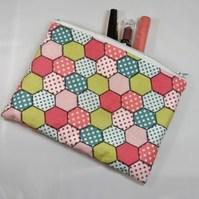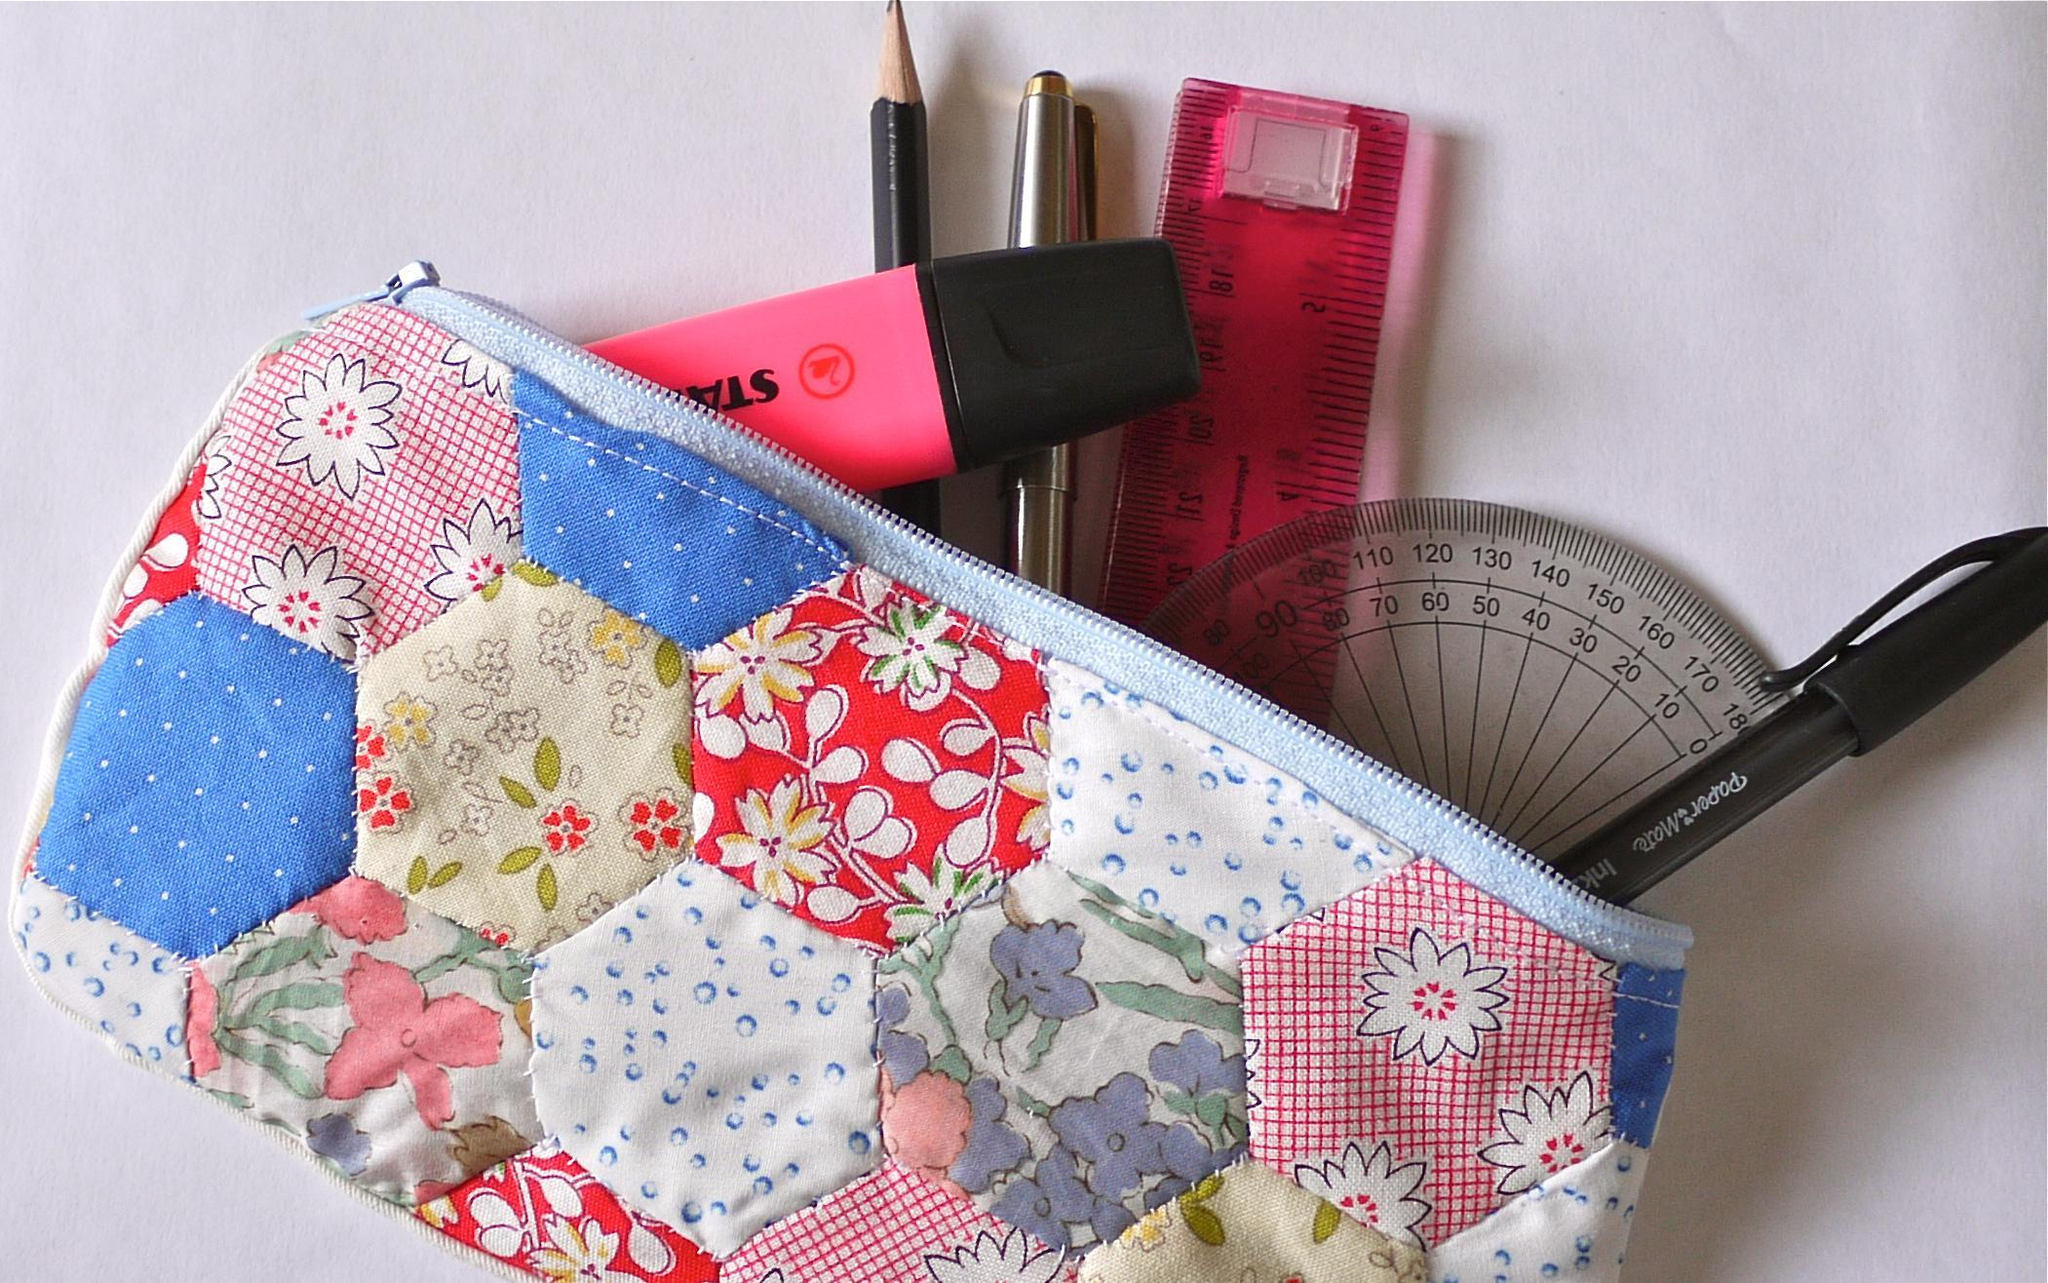The first image is the image on the left, the second image is the image on the right. Given the left and right images, does the statement "Color pencils are poking out of a pencil case in the image on the left." hold true? Answer yes or no. No. The first image is the image on the left, the second image is the image on the right. Considering the images on both sides, is "An image shows a set of colored pencils sticking out of a soft pencil case." valid? Answer yes or no. No. 